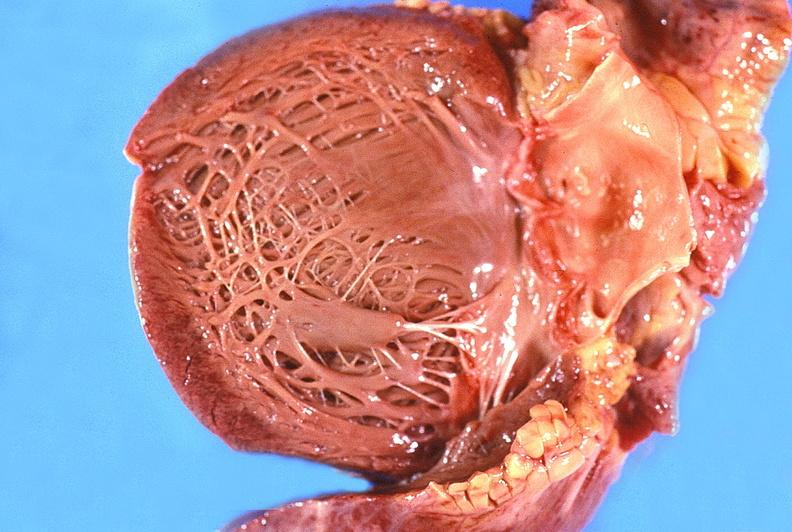s cardiovascular present?
Answer the question using a single word or phrase. Yes 